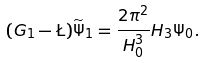<formula> <loc_0><loc_0><loc_500><loc_500>( G _ { 1 } - \L ) \widetilde { \Psi } _ { 1 } = \frac { 2 \pi ^ { 2 } } { H _ { 0 } ^ { 3 } } H _ { 3 } \Psi _ { 0 } .</formula> 